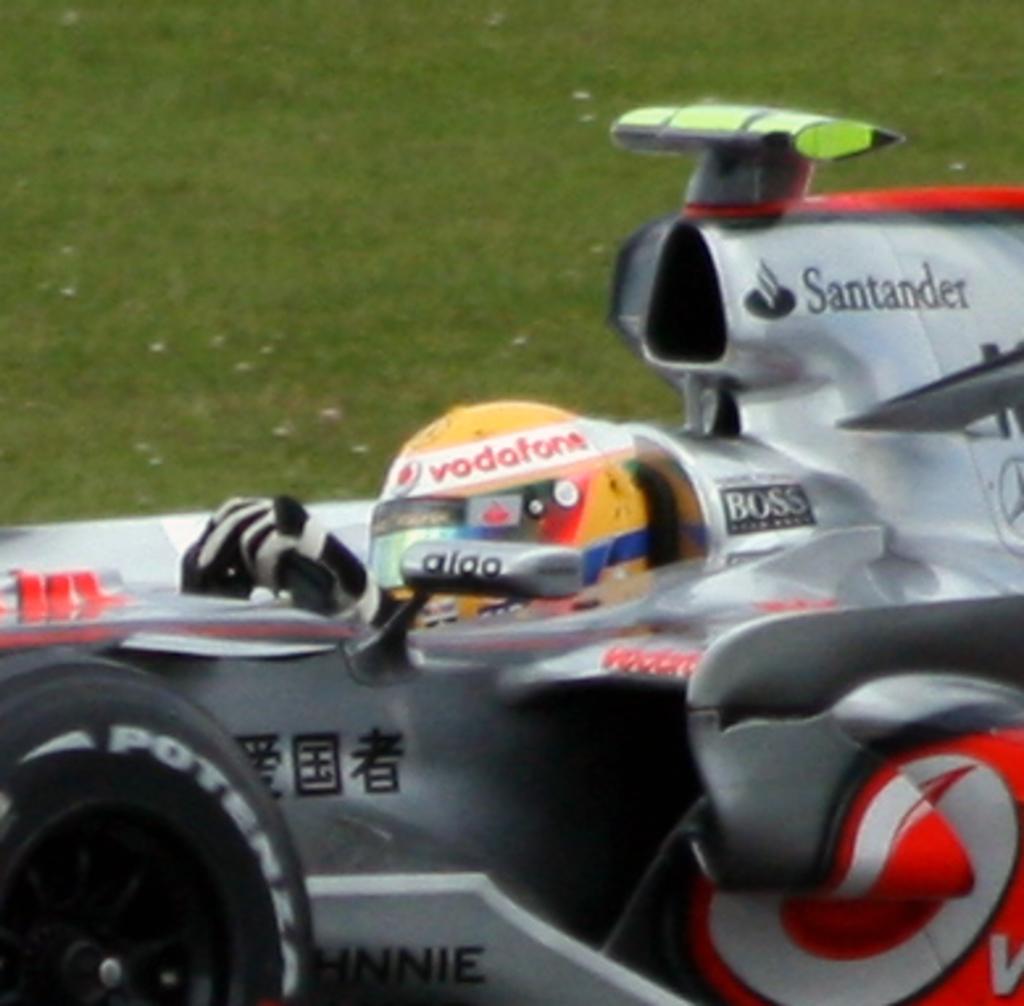What is one of the brands endorsing this driver?
Your response must be concise. Santander. What brand is on the top of the drivers helmet?
Give a very brief answer. Vodafone. 